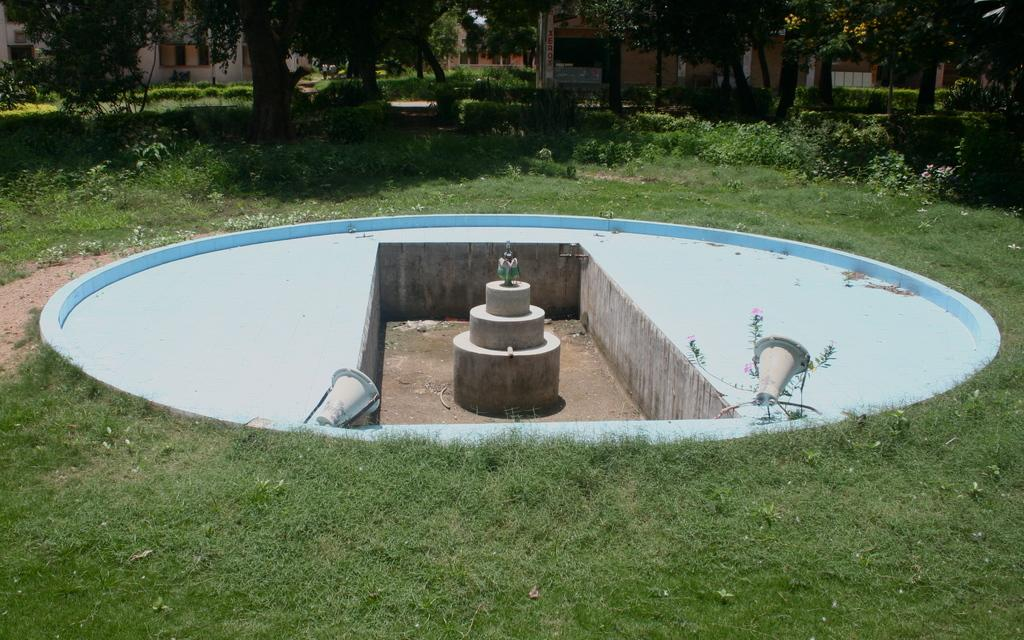What type of structures can be seen in the background of the image? There are houses in the background of the image. What other natural elements are present in the background of the image? There are trees in the background of the image. What types of plants are visible in the image? There are plants, grass, and flowers in the image. What is the condition of the fountain in the image? There is a fountain without water in the image. What type of tax is being collected from the plants in the image? There is no mention of tax collection in the image, and plants do not pay taxes. What color is the tongue of the flower in the image? There is no tongue present in the image, as flowers do not have tongues. 